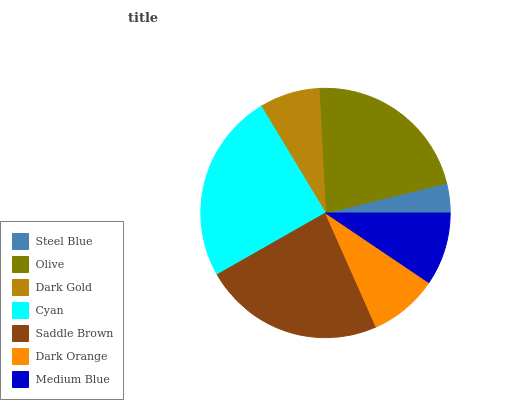Is Steel Blue the minimum?
Answer yes or no. Yes. Is Cyan the maximum?
Answer yes or no. Yes. Is Olive the minimum?
Answer yes or no. No. Is Olive the maximum?
Answer yes or no. No. Is Olive greater than Steel Blue?
Answer yes or no. Yes. Is Steel Blue less than Olive?
Answer yes or no. Yes. Is Steel Blue greater than Olive?
Answer yes or no. No. Is Olive less than Steel Blue?
Answer yes or no. No. Is Medium Blue the high median?
Answer yes or no. Yes. Is Medium Blue the low median?
Answer yes or no. Yes. Is Olive the high median?
Answer yes or no. No. Is Dark Orange the low median?
Answer yes or no. No. 